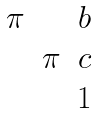<formula> <loc_0><loc_0><loc_500><loc_500>\begin{matrix} \pi & & b \\ & \pi & c \\ & & 1 \end{matrix}</formula> 